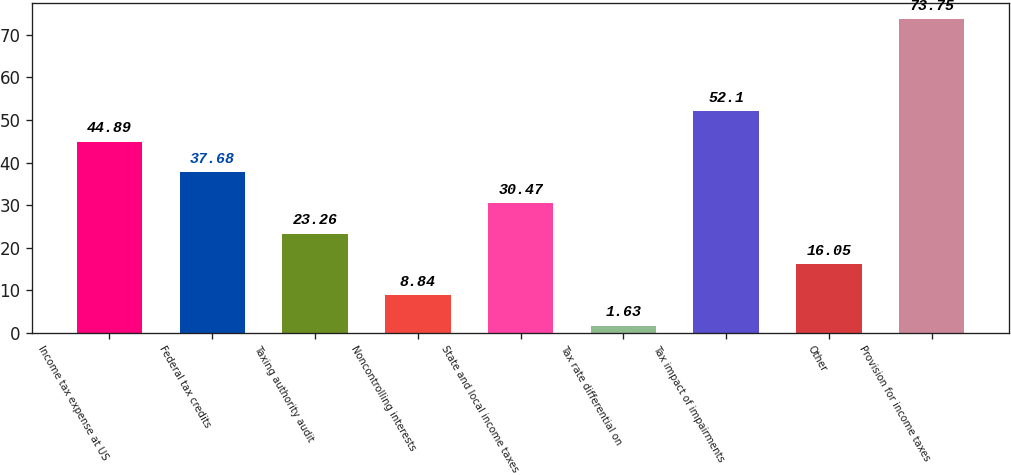Convert chart to OTSL. <chart><loc_0><loc_0><loc_500><loc_500><bar_chart><fcel>Income tax expense at US<fcel>Federal tax credits<fcel>Taxing authority audit<fcel>Noncontrolling interests<fcel>State and local income taxes<fcel>Tax rate differential on<fcel>Tax impact of impairments<fcel>Other<fcel>Provision for income taxes<nl><fcel>44.89<fcel>37.68<fcel>23.26<fcel>8.84<fcel>30.47<fcel>1.63<fcel>52.1<fcel>16.05<fcel>73.75<nl></chart> 